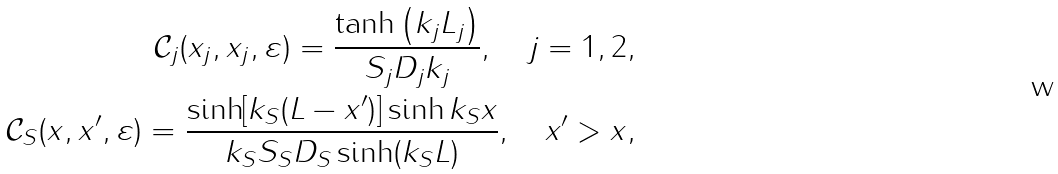Convert formula to latex. <formula><loc_0><loc_0><loc_500><loc_500>\mathcal { C } _ { j } ( x _ { j } , x _ { j } , \varepsilon ) = \frac { \tanh \left ( k _ { j } L _ { j } \right ) } { S _ { j } D _ { j } k _ { j } } , \quad j = 1 , 2 , \\ \mathcal { C } _ { S } ( x , x ^ { \prime } , \varepsilon ) = \frac { \sinh [ k _ { S } ( L - x ^ { \prime } ) ] \sinh k _ { S } x } { k _ { S } S _ { S } D _ { S } \sinh ( k _ { S } L ) } , \quad x ^ { \prime } > x ,</formula> 